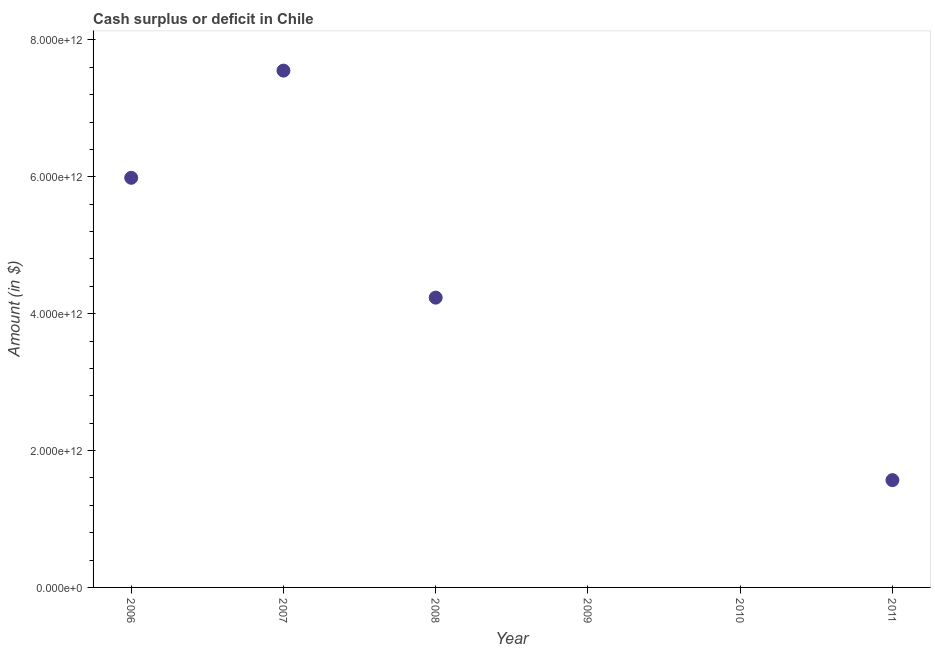What is the cash surplus or deficit in 2006?
Keep it short and to the point. 5.98e+12. Across all years, what is the maximum cash surplus or deficit?
Offer a very short reply. 7.55e+12. In which year was the cash surplus or deficit maximum?
Your answer should be compact. 2007. What is the sum of the cash surplus or deficit?
Provide a short and direct response. 1.93e+13. What is the difference between the cash surplus or deficit in 2008 and 2011?
Your answer should be very brief. 2.67e+12. What is the average cash surplus or deficit per year?
Ensure brevity in your answer.  3.22e+12. What is the median cash surplus or deficit?
Provide a succinct answer. 2.90e+12. What is the ratio of the cash surplus or deficit in 2007 to that in 2011?
Your answer should be compact. 4.82. Is the difference between the cash surplus or deficit in 2007 and 2011 greater than the difference between any two years?
Offer a very short reply. No. What is the difference between the highest and the second highest cash surplus or deficit?
Offer a very short reply. 1.57e+12. What is the difference between the highest and the lowest cash surplus or deficit?
Your answer should be very brief. 7.55e+12. How many dotlines are there?
Offer a terse response. 1. What is the difference between two consecutive major ticks on the Y-axis?
Your answer should be very brief. 2.00e+12. What is the title of the graph?
Make the answer very short. Cash surplus or deficit in Chile. What is the label or title of the Y-axis?
Offer a very short reply. Amount (in $). What is the Amount (in $) in 2006?
Give a very brief answer. 5.98e+12. What is the Amount (in $) in 2007?
Ensure brevity in your answer.  7.55e+12. What is the Amount (in $) in 2008?
Keep it short and to the point. 4.23e+12. What is the Amount (in $) in 2011?
Keep it short and to the point. 1.57e+12. What is the difference between the Amount (in $) in 2006 and 2007?
Ensure brevity in your answer.  -1.57e+12. What is the difference between the Amount (in $) in 2006 and 2008?
Offer a very short reply. 1.75e+12. What is the difference between the Amount (in $) in 2006 and 2011?
Offer a terse response. 4.42e+12. What is the difference between the Amount (in $) in 2007 and 2008?
Offer a very short reply. 3.32e+12. What is the difference between the Amount (in $) in 2007 and 2011?
Offer a terse response. 5.98e+12. What is the difference between the Amount (in $) in 2008 and 2011?
Offer a terse response. 2.67e+12. What is the ratio of the Amount (in $) in 2006 to that in 2007?
Ensure brevity in your answer.  0.79. What is the ratio of the Amount (in $) in 2006 to that in 2008?
Provide a succinct answer. 1.41. What is the ratio of the Amount (in $) in 2006 to that in 2011?
Provide a succinct answer. 3.82. What is the ratio of the Amount (in $) in 2007 to that in 2008?
Offer a terse response. 1.78. What is the ratio of the Amount (in $) in 2007 to that in 2011?
Your response must be concise. 4.82. What is the ratio of the Amount (in $) in 2008 to that in 2011?
Offer a terse response. 2.7. 